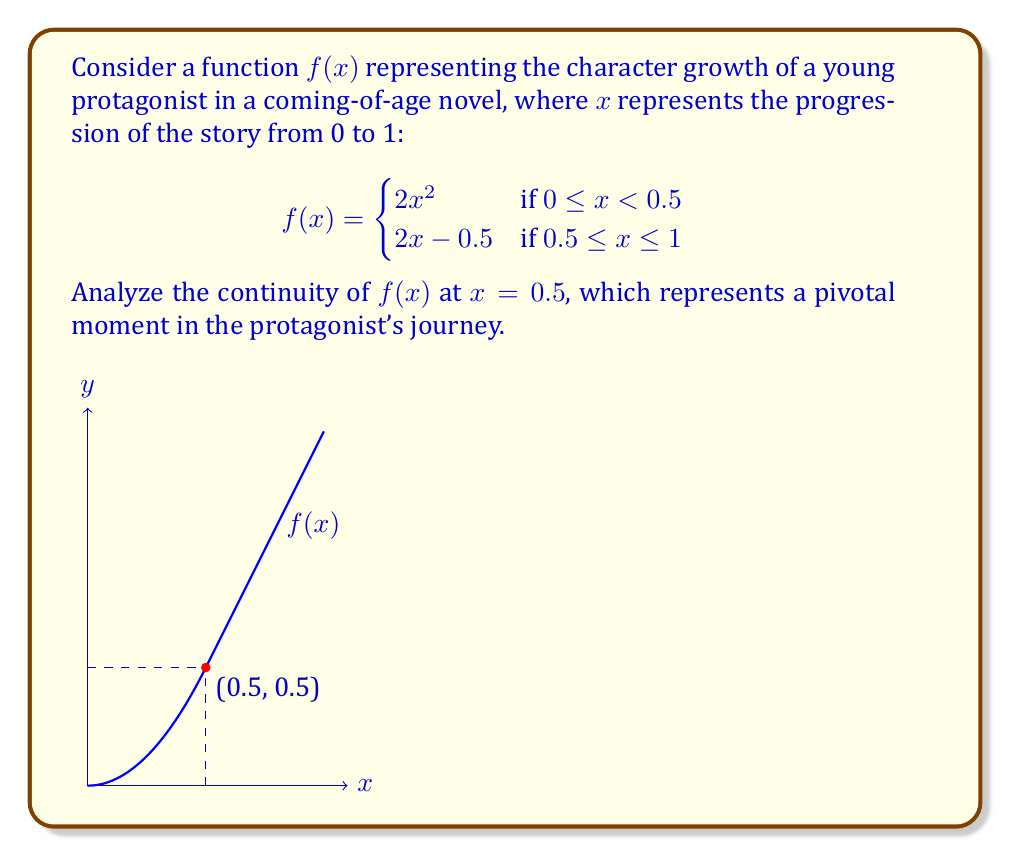Provide a solution to this math problem. To analyze the continuity of $f(x)$ at $x = 0.5$, we need to check three conditions:

1. $f(x)$ is defined at $x = 0.5$
2. $\lim_{x \to 0.5^-} f(x)$ exists
3. $\lim_{x \to 0.5^+} f(x)$ exists
4. $\lim_{x \to 0.5^-} f(x) = \lim_{x \to 0.5^+} f(x) = f(0.5)$

Step 1: Check if $f(x)$ is defined at $x = 0.5$
$f(0.5) = 2(0.5) - 0.5 = 0.5$, so $f(x)$ is defined at $x = 0.5$.

Step 2: Calculate $\lim_{x \to 0.5^-} f(x)$
$\lim_{x \to 0.5^-} f(x) = \lim_{x \to 0.5^-} 2x^2 = 2(0.5)^2 = 0.5$

Step 3: Calculate $\lim_{x \to 0.5^+} f(x)$
$\lim_{x \to 0.5^+} f(x) = \lim_{x \to 0.5^+} (2x-0.5) = 2(0.5)-0.5 = 0.5$

Step 4: Compare the limits and $f(0.5)$
$\lim_{x \to 0.5^-} f(x) = \lim_{x \to 0.5^+} f(x) = f(0.5) = 0.5$

Since all three conditions are satisfied, $f(x)$ is continuous at $x = 0.5$.

This continuity represents a smooth transition in the protagonist's character growth at the pivotal moment in the story, despite the change in the rate of growth.
Answer: $f(x)$ is continuous at $x = 0.5$ 